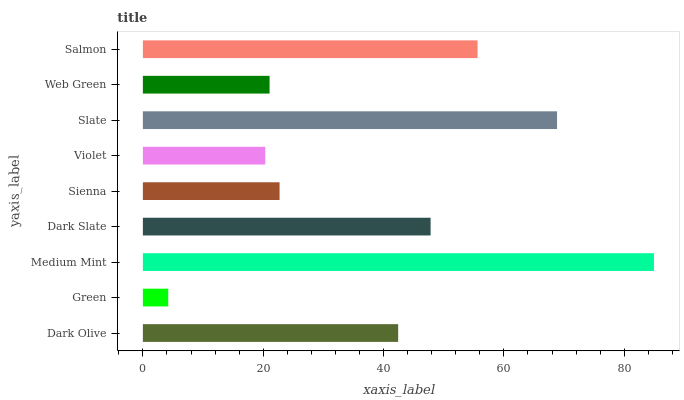Is Green the minimum?
Answer yes or no. Yes. Is Medium Mint the maximum?
Answer yes or no. Yes. Is Medium Mint the minimum?
Answer yes or no. No. Is Green the maximum?
Answer yes or no. No. Is Medium Mint greater than Green?
Answer yes or no. Yes. Is Green less than Medium Mint?
Answer yes or no. Yes. Is Green greater than Medium Mint?
Answer yes or no. No. Is Medium Mint less than Green?
Answer yes or no. No. Is Dark Olive the high median?
Answer yes or no. Yes. Is Dark Olive the low median?
Answer yes or no. Yes. Is Violet the high median?
Answer yes or no. No. Is Sienna the low median?
Answer yes or no. No. 